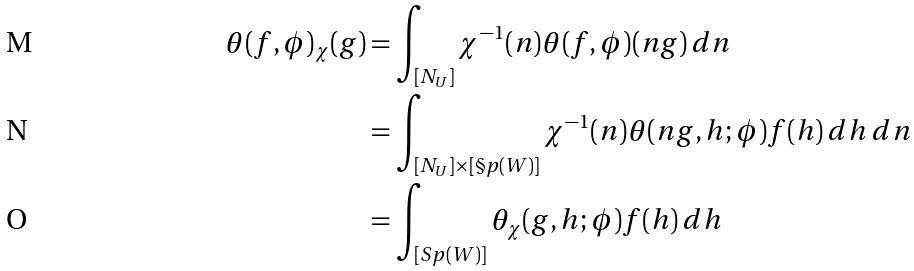<formula> <loc_0><loc_0><loc_500><loc_500>\theta ( f , \phi ) _ { \chi } ( g ) & = \int _ { [ N _ { U } ] } { \chi ^ { - 1 } ( n ) \theta ( f , \phi ) ( n g ) \, d n } \\ & = \int _ { [ N _ { U } ] \times [ \S p ( W ) ] } { \chi ^ { - 1 } ( n ) \theta ( n g , h ; \phi ) f ( h ) \, d h \, d n } \\ & = \int _ { [ S p ( W ) ] } { \theta _ { \chi } ( g , h ; \phi ) f ( h ) \, d h }</formula> 